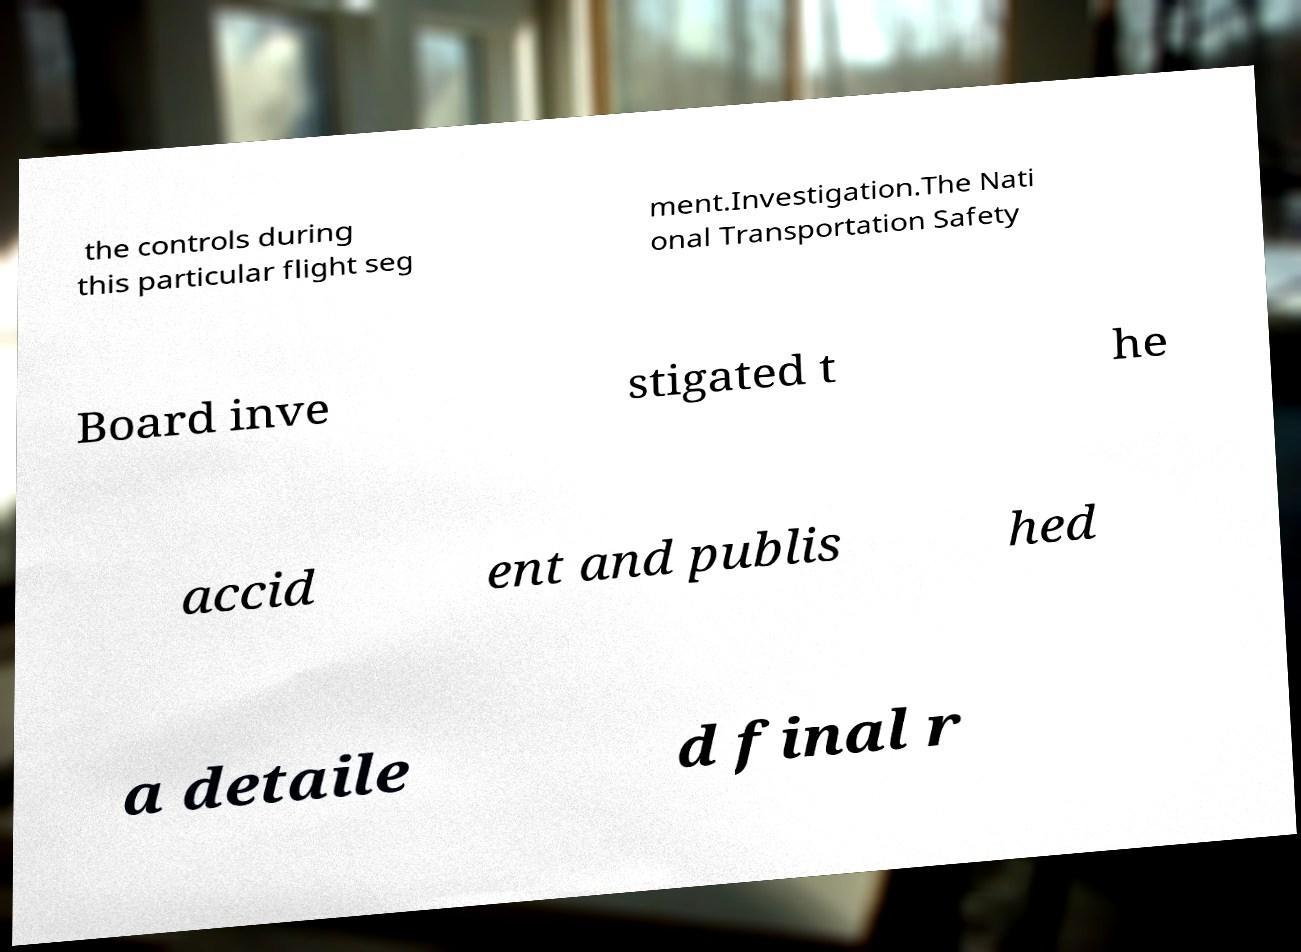I need the written content from this picture converted into text. Can you do that? the controls during this particular flight seg ment.Investigation.The Nati onal Transportation Safety Board inve stigated t he accid ent and publis hed a detaile d final r 